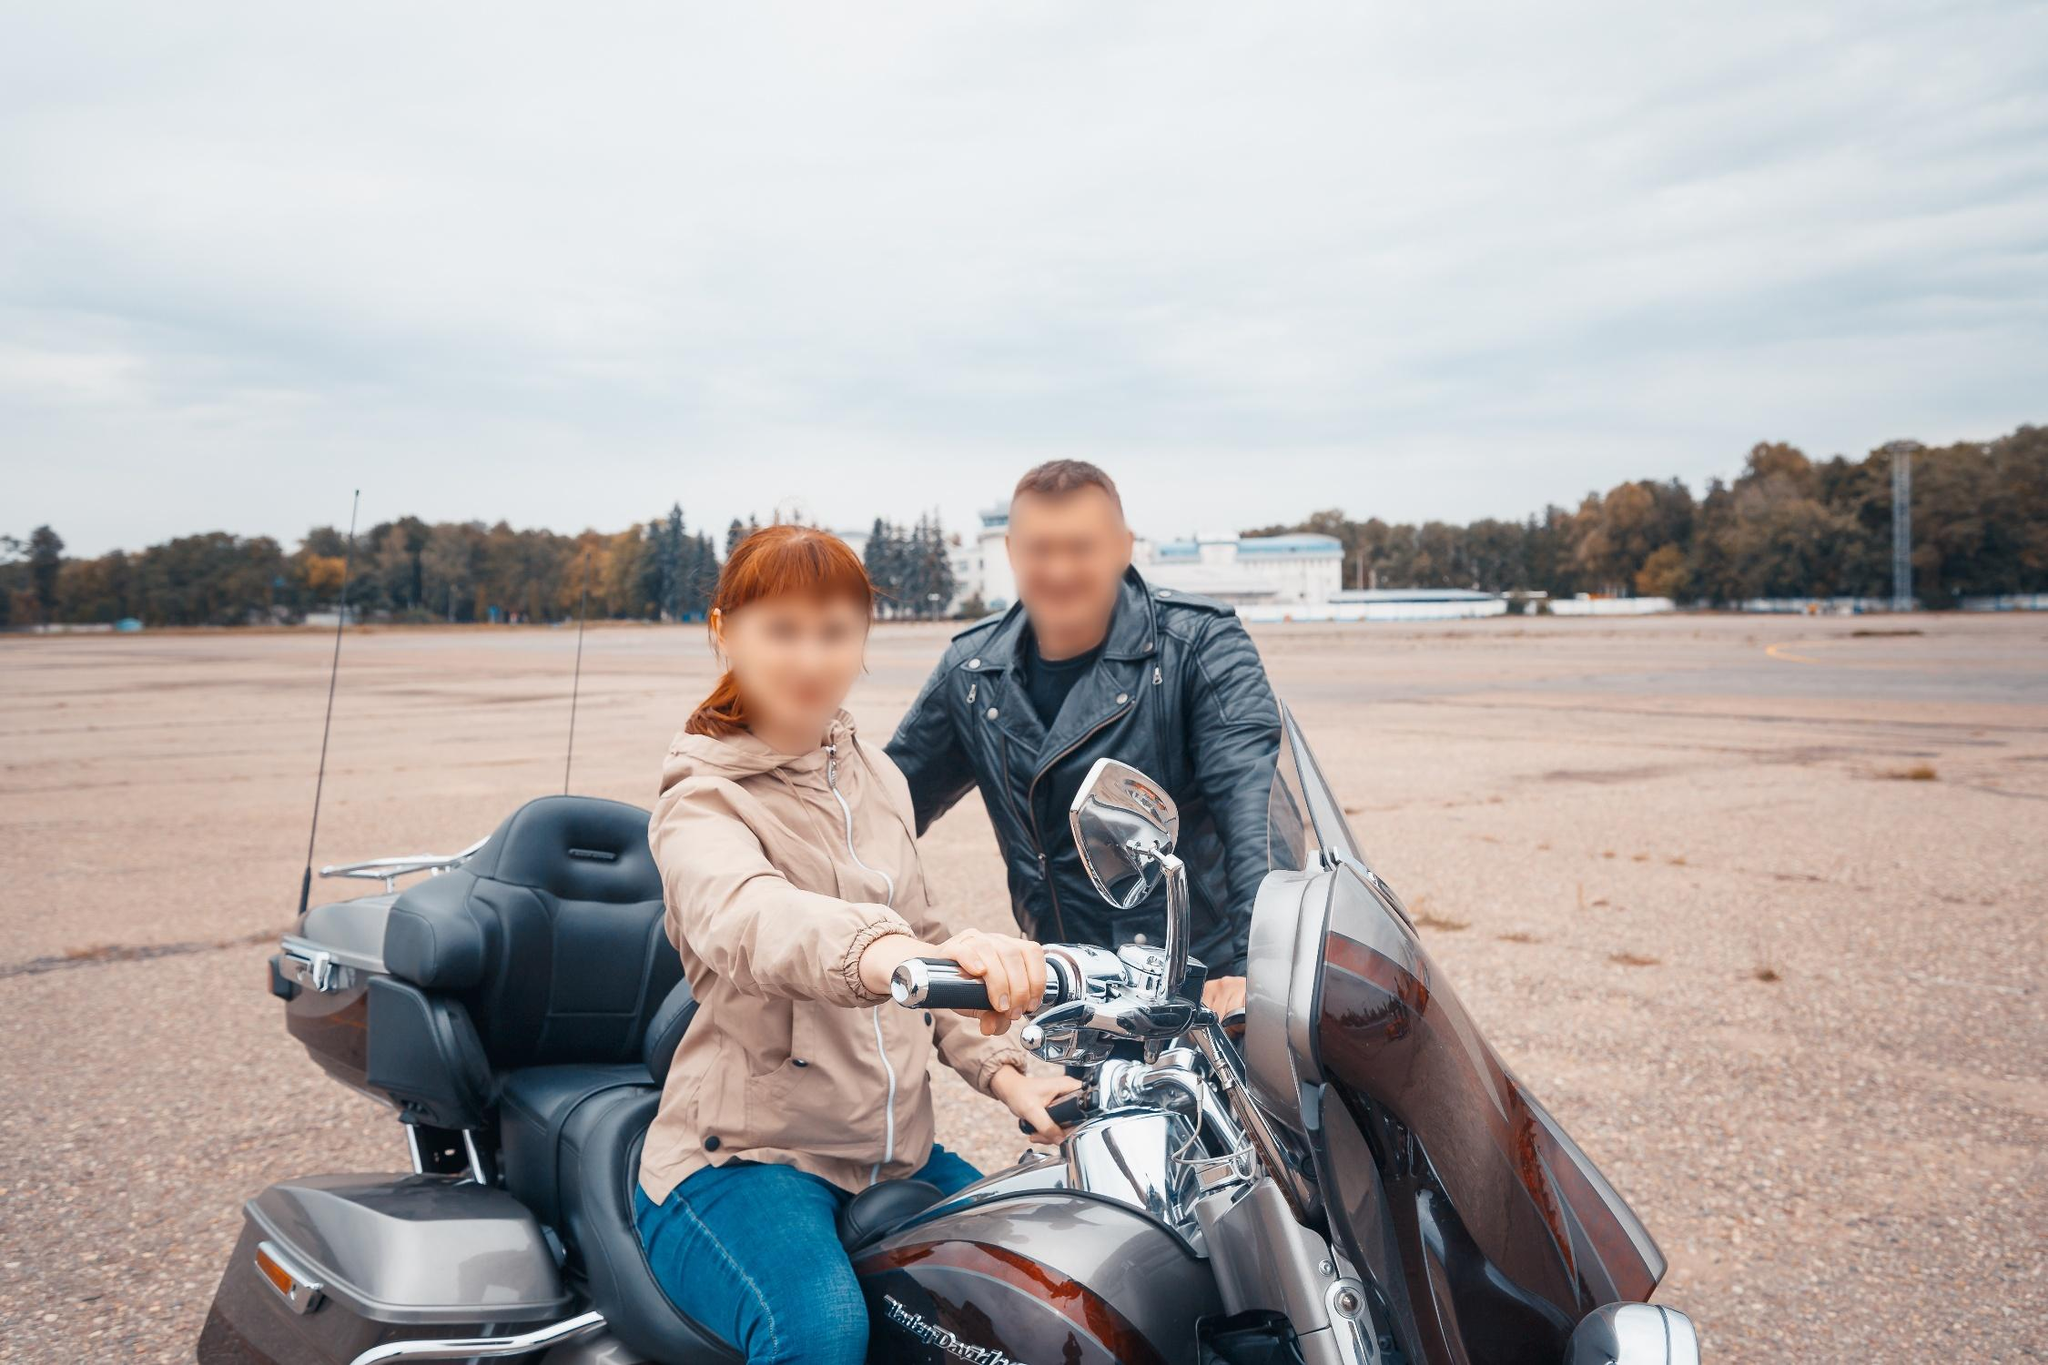Describe a realistic scenario where this image could have been taken and a possible story behind it. The image might have been captured during a weekend ride where the couple decided to explore the outskirts of their town. They found a quiet, abandoned airstrip perfect for a break and a photoshoot. The man and woman, both motorcycle enthusiasts, often spend their free time finding new, picturesque locations to visit. This particular outing marks the end of a long work week, providing them with a much-needed escape and time to bond over their shared passion. The overcast sky and serene surroundings set a reflective mood, hinting at deeper conversations and a strong companionship.  What could they be discussing as they prepare to ride off? As they prepare to ride off, they could be discussing their next destination, perhaps debating between exploring a nearby scenic route or visiting a popular diner recommended by fellow riders. They might also be planning future rides, sharing stories of past adventures, or simply enjoying a quiet moment of camaraderie and the thrill of the open road. 